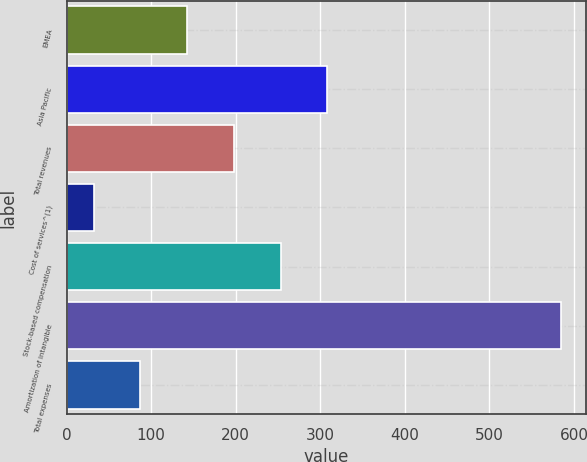<chart> <loc_0><loc_0><loc_500><loc_500><bar_chart><fcel>EMEA<fcel>Asia Pacific<fcel>Total revenues<fcel>Cost of services^(1)<fcel>Stock-based compensation<fcel>Amortization of intangible<fcel>Total expenses<nl><fcel>142.6<fcel>308.5<fcel>197.9<fcel>32<fcel>253.2<fcel>585<fcel>87.3<nl></chart> 